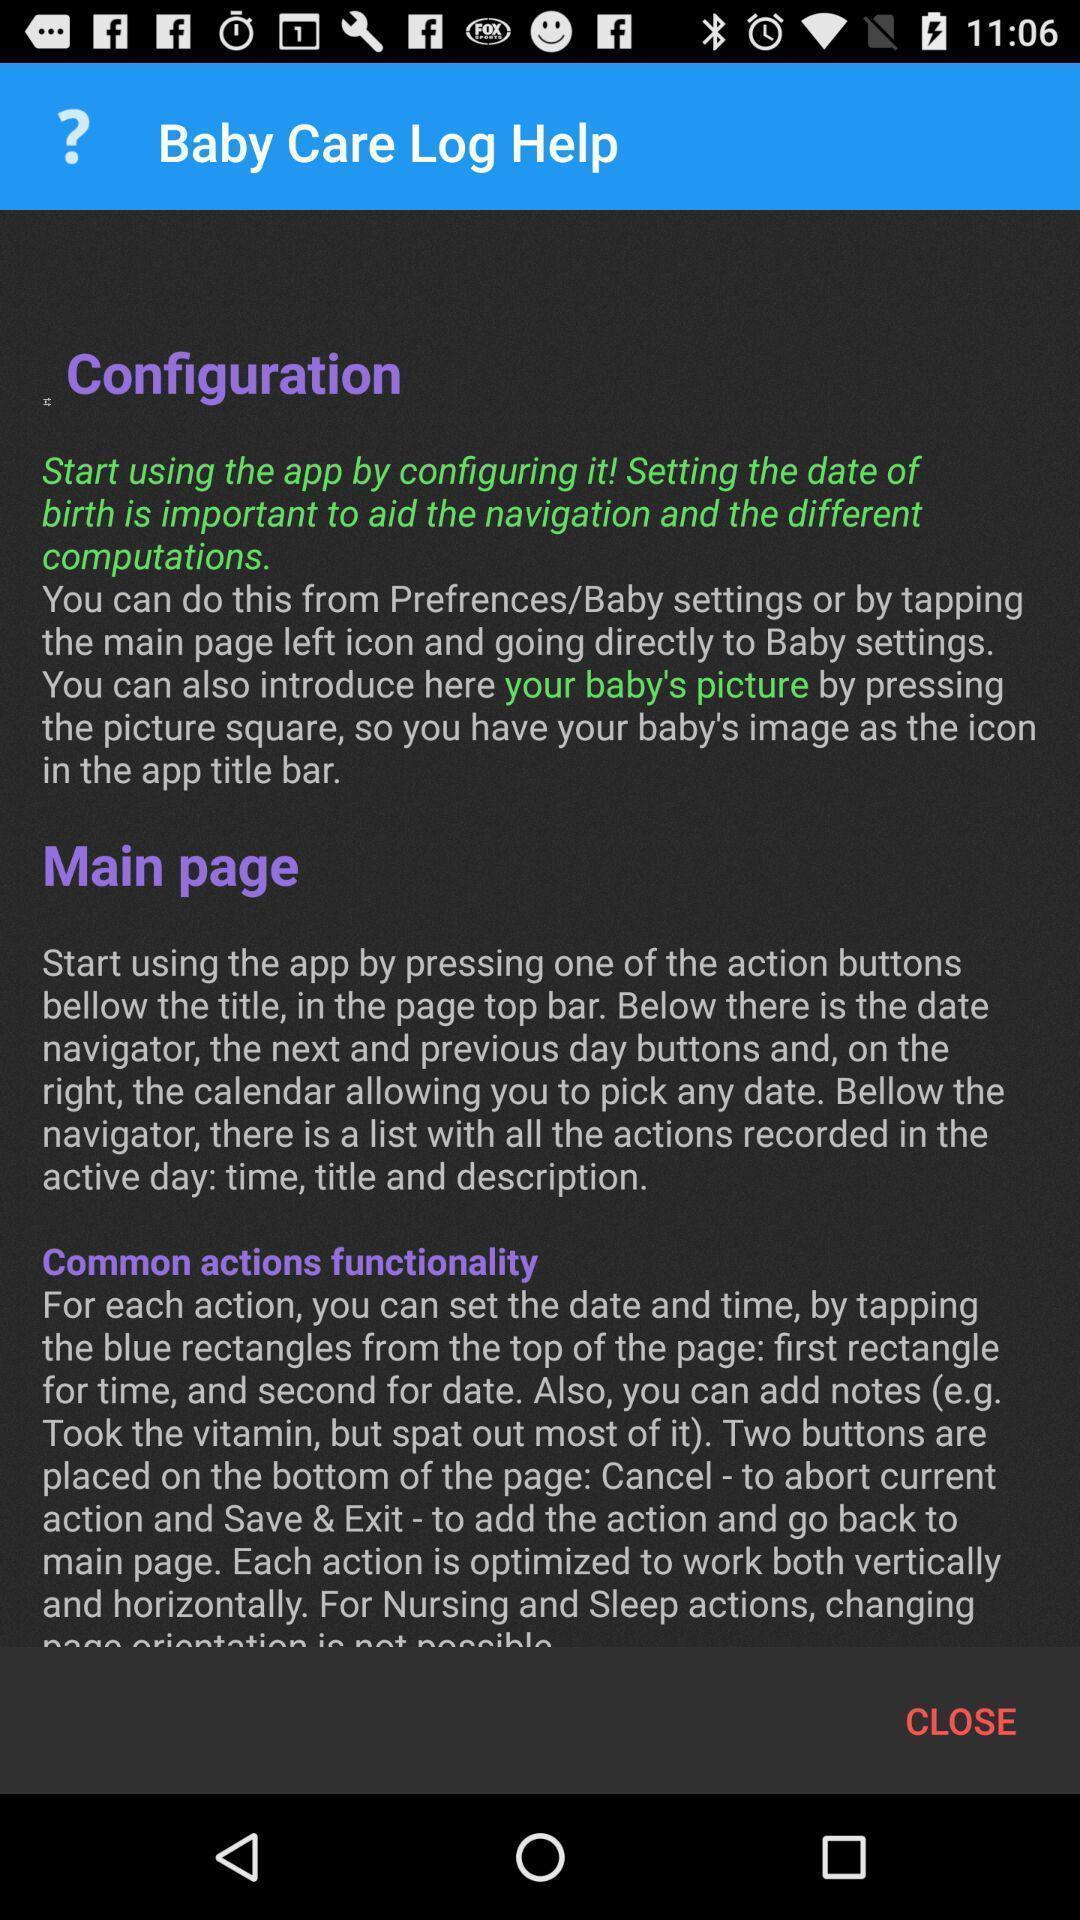Explain what's happening in this screen capture. Welcome page of a baby care app. 